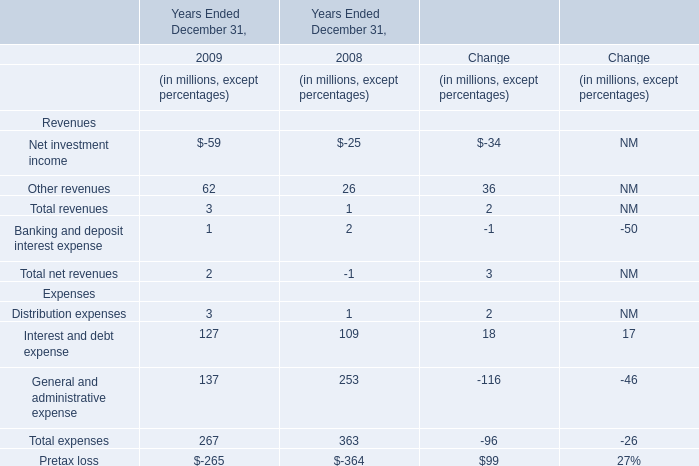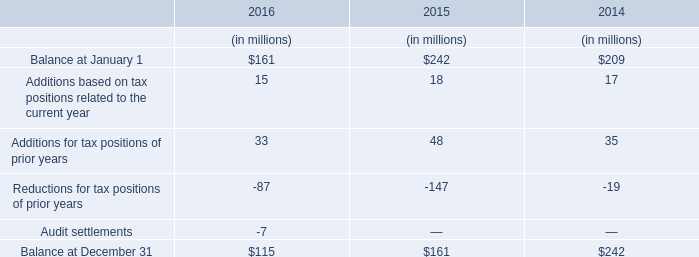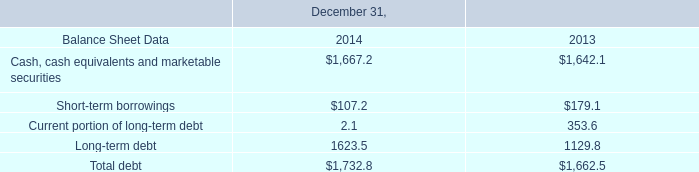In the year with largest amount of Interest and debt expense, what's the increasing rate of Total expenses? 
Computations: ((267 - 363) / 363)
Answer: -0.26446. 